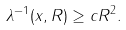<formula> <loc_0><loc_0><loc_500><loc_500>\lambda ^ { - 1 } ( x , R ) \geq c R ^ { 2 } .</formula> 